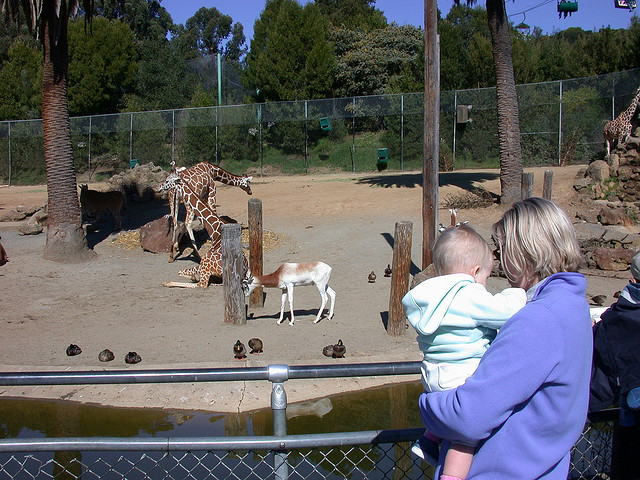<image>What color is the plastic container inside the cage? I don't know what color is the plastic container inside the cage. It can be brown, green, gray, white or tan. What color is the plastic container inside the cage? I am not sure what color the plastic container inside the cage is. It can be seen as brown, green, gray, white, or tan. 